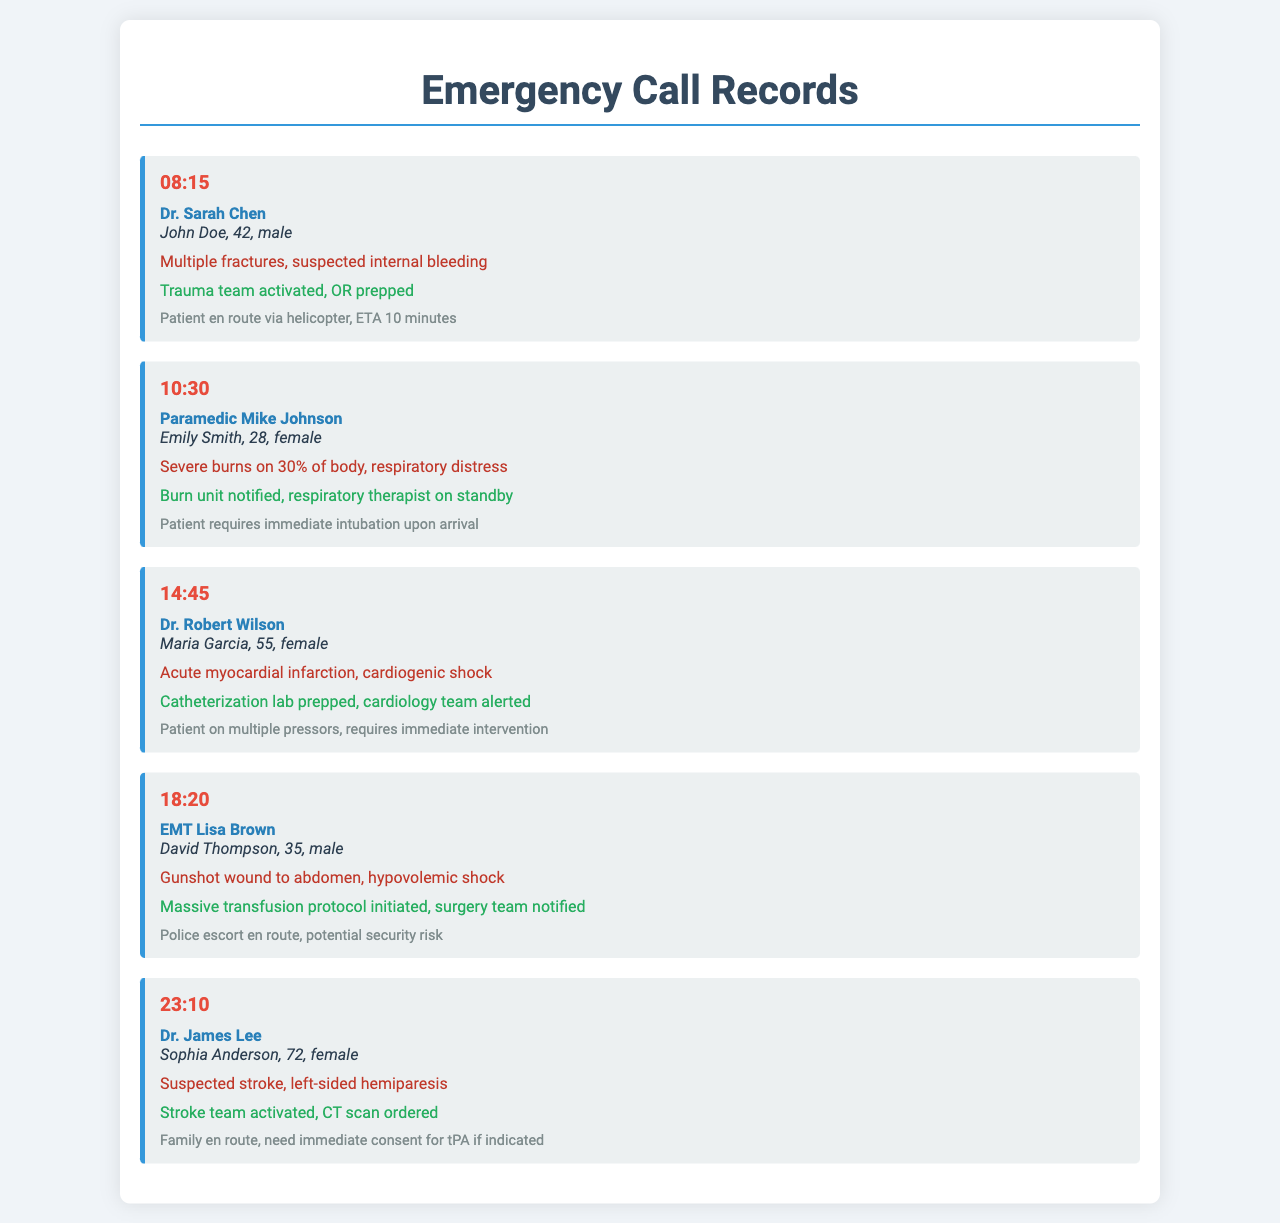What time was the first call received? The first call was received at 08:15.
Answer: 08:15 Who was the caller regarding John Doe? The caller was Dr. Sarah Chen.
Answer: Dr. Sarah Chen What is the injury detail for Emily Smith? Emily Smith has severe burns on 30% of her body.
Answer: Severe burns on 30% of body What action was taken for Maria Garcia? The catheterization lab was prepped and the cardiology team was alerted.
Answer: Catheterization lab prepped, cardiology team alerted How many patients required immediate intubation? Only one patient, Emily Smith, required immediate intubation.
Answer: One patient What common symptom was noted for Sophia Anderson? Sophia Anderson had left-sided hemiparesis.
Answer: Left-sided hemiparesis What is the additional note for the call regarding David Thompson? The additional note mentions a police escort en route and potential security risk.
Answer: Police escort en route, potential security risk Which team was activated for the call at 23:10? The stroke team was activated.
Answer: Stroke team activated What was the injury detail for David Thompson? David Thompson had a gunshot wound to the abdomen and hypovolemic shock.
Answer: Gunshot wound to abdomen, hypovolemic shock 